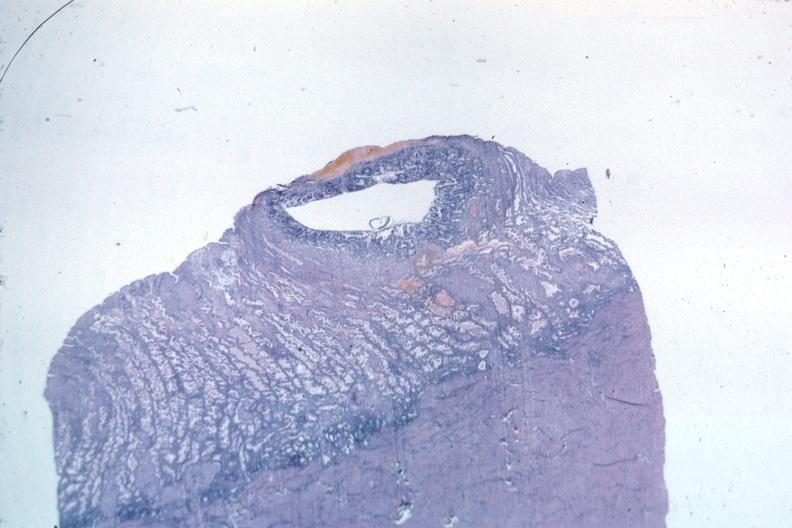s lymphoma present?
Answer the question using a single word or phrase. No 